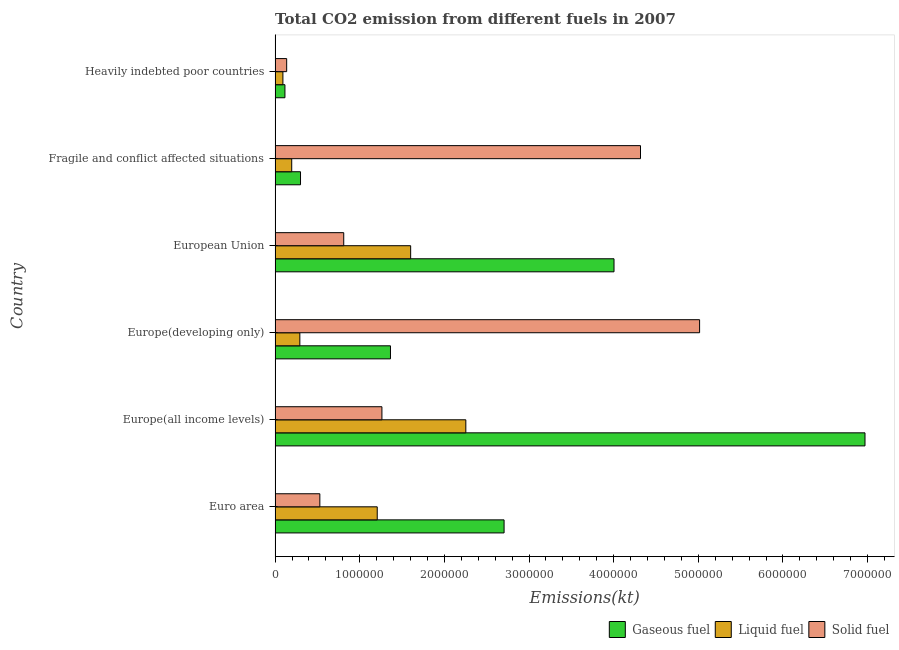What is the label of the 4th group of bars from the top?
Offer a very short reply. Europe(developing only). What is the amount of co2 emissions from liquid fuel in Heavily indebted poor countries?
Offer a terse response. 9.25e+04. Across all countries, what is the maximum amount of co2 emissions from solid fuel?
Make the answer very short. 5.02e+06. Across all countries, what is the minimum amount of co2 emissions from liquid fuel?
Keep it short and to the point. 9.25e+04. In which country was the amount of co2 emissions from solid fuel maximum?
Provide a succinct answer. Europe(developing only). In which country was the amount of co2 emissions from liquid fuel minimum?
Make the answer very short. Heavily indebted poor countries. What is the total amount of co2 emissions from solid fuel in the graph?
Provide a short and direct response. 1.21e+07. What is the difference between the amount of co2 emissions from solid fuel in Europe(developing only) and that in European Union?
Your answer should be very brief. 4.20e+06. What is the difference between the amount of co2 emissions from solid fuel in Europe(developing only) and the amount of co2 emissions from liquid fuel in Europe(all income levels)?
Offer a terse response. 2.76e+06. What is the average amount of co2 emissions from solid fuel per country?
Provide a short and direct response. 2.01e+06. What is the difference between the amount of co2 emissions from gaseous fuel and amount of co2 emissions from liquid fuel in Europe(developing only)?
Give a very brief answer. 1.07e+06. In how many countries, is the amount of co2 emissions from gaseous fuel greater than 3000000 kt?
Give a very brief answer. 2. What is the ratio of the amount of co2 emissions from gaseous fuel in Europe(all income levels) to that in Fragile and conflict affected situations?
Keep it short and to the point. 23.2. Is the difference between the amount of co2 emissions from solid fuel in Europe(all income levels) and European Union greater than the difference between the amount of co2 emissions from liquid fuel in Europe(all income levels) and European Union?
Provide a succinct answer. No. What is the difference between the highest and the second highest amount of co2 emissions from solid fuel?
Give a very brief answer. 6.98e+05. What is the difference between the highest and the lowest amount of co2 emissions from liquid fuel?
Ensure brevity in your answer.  2.16e+06. What does the 2nd bar from the top in Fragile and conflict affected situations represents?
Your answer should be compact. Liquid fuel. What does the 1st bar from the bottom in Fragile and conflict affected situations represents?
Provide a succinct answer. Gaseous fuel. How many bars are there?
Provide a succinct answer. 18. How many countries are there in the graph?
Give a very brief answer. 6. What is the difference between two consecutive major ticks on the X-axis?
Your response must be concise. 1.00e+06. Are the values on the major ticks of X-axis written in scientific E-notation?
Your answer should be compact. No. How many legend labels are there?
Your answer should be very brief. 3. How are the legend labels stacked?
Provide a short and direct response. Horizontal. What is the title of the graph?
Offer a very short reply. Total CO2 emission from different fuels in 2007. Does "Ages 20-60" appear as one of the legend labels in the graph?
Your answer should be compact. No. What is the label or title of the X-axis?
Your response must be concise. Emissions(kt). What is the label or title of the Y-axis?
Your answer should be very brief. Country. What is the Emissions(kt) in Gaseous fuel in Euro area?
Your answer should be compact. 2.71e+06. What is the Emissions(kt) of Liquid fuel in Euro area?
Your answer should be compact. 1.21e+06. What is the Emissions(kt) in Solid fuel in Euro area?
Your answer should be very brief. 5.29e+05. What is the Emissions(kt) in Gaseous fuel in Europe(all income levels)?
Make the answer very short. 6.97e+06. What is the Emissions(kt) in Liquid fuel in Europe(all income levels)?
Offer a terse response. 2.25e+06. What is the Emissions(kt) of Solid fuel in Europe(all income levels)?
Offer a terse response. 1.26e+06. What is the Emissions(kt) in Gaseous fuel in Europe(developing only)?
Ensure brevity in your answer.  1.36e+06. What is the Emissions(kt) of Liquid fuel in Europe(developing only)?
Your response must be concise. 2.93e+05. What is the Emissions(kt) of Solid fuel in Europe(developing only)?
Make the answer very short. 5.02e+06. What is the Emissions(kt) in Gaseous fuel in European Union?
Your response must be concise. 4.00e+06. What is the Emissions(kt) in Liquid fuel in European Union?
Keep it short and to the point. 1.60e+06. What is the Emissions(kt) of Solid fuel in European Union?
Offer a very short reply. 8.11e+05. What is the Emissions(kt) of Gaseous fuel in Fragile and conflict affected situations?
Provide a succinct answer. 3.00e+05. What is the Emissions(kt) of Liquid fuel in Fragile and conflict affected situations?
Your answer should be compact. 1.97e+05. What is the Emissions(kt) of Solid fuel in Fragile and conflict affected situations?
Make the answer very short. 4.32e+06. What is the Emissions(kt) in Gaseous fuel in Heavily indebted poor countries?
Offer a terse response. 1.16e+05. What is the Emissions(kt) of Liquid fuel in Heavily indebted poor countries?
Give a very brief answer. 9.25e+04. What is the Emissions(kt) of Solid fuel in Heavily indebted poor countries?
Ensure brevity in your answer.  1.37e+05. Across all countries, what is the maximum Emissions(kt) of Gaseous fuel?
Make the answer very short. 6.97e+06. Across all countries, what is the maximum Emissions(kt) in Liquid fuel?
Keep it short and to the point. 2.25e+06. Across all countries, what is the maximum Emissions(kt) in Solid fuel?
Your answer should be very brief. 5.02e+06. Across all countries, what is the minimum Emissions(kt) in Gaseous fuel?
Your answer should be very brief. 1.16e+05. Across all countries, what is the minimum Emissions(kt) in Liquid fuel?
Your answer should be compact. 9.25e+04. Across all countries, what is the minimum Emissions(kt) of Solid fuel?
Keep it short and to the point. 1.37e+05. What is the total Emissions(kt) in Gaseous fuel in the graph?
Offer a very short reply. 1.55e+07. What is the total Emissions(kt) in Liquid fuel in the graph?
Ensure brevity in your answer.  5.64e+06. What is the total Emissions(kt) in Solid fuel in the graph?
Provide a short and direct response. 1.21e+07. What is the difference between the Emissions(kt) in Gaseous fuel in Euro area and that in Europe(all income levels)?
Offer a very short reply. -4.26e+06. What is the difference between the Emissions(kt) in Liquid fuel in Euro area and that in Europe(all income levels)?
Your answer should be compact. -1.05e+06. What is the difference between the Emissions(kt) of Solid fuel in Euro area and that in Europe(all income levels)?
Offer a terse response. -7.33e+05. What is the difference between the Emissions(kt) in Gaseous fuel in Euro area and that in Europe(developing only)?
Provide a succinct answer. 1.34e+06. What is the difference between the Emissions(kt) in Liquid fuel in Euro area and that in Europe(developing only)?
Offer a very short reply. 9.14e+05. What is the difference between the Emissions(kt) of Solid fuel in Euro area and that in Europe(developing only)?
Your response must be concise. -4.49e+06. What is the difference between the Emissions(kt) of Gaseous fuel in Euro area and that in European Union?
Offer a very short reply. -1.30e+06. What is the difference between the Emissions(kt) of Liquid fuel in Euro area and that in European Union?
Keep it short and to the point. -3.95e+05. What is the difference between the Emissions(kt) of Solid fuel in Euro area and that in European Union?
Provide a short and direct response. -2.82e+05. What is the difference between the Emissions(kt) of Gaseous fuel in Euro area and that in Fragile and conflict affected situations?
Your response must be concise. 2.41e+06. What is the difference between the Emissions(kt) in Liquid fuel in Euro area and that in Fragile and conflict affected situations?
Your answer should be compact. 1.01e+06. What is the difference between the Emissions(kt) of Solid fuel in Euro area and that in Fragile and conflict affected situations?
Keep it short and to the point. -3.79e+06. What is the difference between the Emissions(kt) in Gaseous fuel in Euro area and that in Heavily indebted poor countries?
Give a very brief answer. 2.59e+06. What is the difference between the Emissions(kt) of Liquid fuel in Euro area and that in Heavily indebted poor countries?
Offer a very short reply. 1.11e+06. What is the difference between the Emissions(kt) in Solid fuel in Euro area and that in Heavily indebted poor countries?
Ensure brevity in your answer.  3.92e+05. What is the difference between the Emissions(kt) of Gaseous fuel in Europe(all income levels) and that in Europe(developing only)?
Make the answer very short. 5.61e+06. What is the difference between the Emissions(kt) of Liquid fuel in Europe(all income levels) and that in Europe(developing only)?
Offer a very short reply. 1.96e+06. What is the difference between the Emissions(kt) in Solid fuel in Europe(all income levels) and that in Europe(developing only)?
Keep it short and to the point. -3.75e+06. What is the difference between the Emissions(kt) in Gaseous fuel in Europe(all income levels) and that in European Union?
Provide a succinct answer. 2.97e+06. What is the difference between the Emissions(kt) in Liquid fuel in Europe(all income levels) and that in European Union?
Your answer should be very brief. 6.52e+05. What is the difference between the Emissions(kt) of Solid fuel in Europe(all income levels) and that in European Union?
Keep it short and to the point. 4.51e+05. What is the difference between the Emissions(kt) in Gaseous fuel in Europe(all income levels) and that in Fragile and conflict affected situations?
Your answer should be very brief. 6.67e+06. What is the difference between the Emissions(kt) in Liquid fuel in Europe(all income levels) and that in Fragile and conflict affected situations?
Your answer should be compact. 2.06e+06. What is the difference between the Emissions(kt) in Solid fuel in Europe(all income levels) and that in Fragile and conflict affected situations?
Offer a terse response. -3.05e+06. What is the difference between the Emissions(kt) of Gaseous fuel in Europe(all income levels) and that in Heavily indebted poor countries?
Your answer should be very brief. 6.85e+06. What is the difference between the Emissions(kt) of Liquid fuel in Europe(all income levels) and that in Heavily indebted poor countries?
Provide a succinct answer. 2.16e+06. What is the difference between the Emissions(kt) of Solid fuel in Europe(all income levels) and that in Heavily indebted poor countries?
Provide a succinct answer. 1.13e+06. What is the difference between the Emissions(kt) in Gaseous fuel in Europe(developing only) and that in European Union?
Offer a terse response. -2.64e+06. What is the difference between the Emissions(kt) in Liquid fuel in Europe(developing only) and that in European Union?
Ensure brevity in your answer.  -1.31e+06. What is the difference between the Emissions(kt) in Solid fuel in Europe(developing only) and that in European Union?
Your answer should be very brief. 4.20e+06. What is the difference between the Emissions(kt) in Gaseous fuel in Europe(developing only) and that in Fragile and conflict affected situations?
Offer a very short reply. 1.06e+06. What is the difference between the Emissions(kt) of Liquid fuel in Europe(developing only) and that in Fragile and conflict affected situations?
Make the answer very short. 9.60e+04. What is the difference between the Emissions(kt) in Solid fuel in Europe(developing only) and that in Fragile and conflict affected situations?
Your answer should be very brief. 6.98e+05. What is the difference between the Emissions(kt) in Gaseous fuel in Europe(developing only) and that in Heavily indebted poor countries?
Your answer should be compact. 1.25e+06. What is the difference between the Emissions(kt) of Liquid fuel in Europe(developing only) and that in Heavily indebted poor countries?
Your answer should be very brief. 2.00e+05. What is the difference between the Emissions(kt) of Solid fuel in Europe(developing only) and that in Heavily indebted poor countries?
Provide a succinct answer. 4.88e+06. What is the difference between the Emissions(kt) in Gaseous fuel in European Union and that in Fragile and conflict affected situations?
Make the answer very short. 3.70e+06. What is the difference between the Emissions(kt) of Liquid fuel in European Union and that in Fragile and conflict affected situations?
Keep it short and to the point. 1.41e+06. What is the difference between the Emissions(kt) of Solid fuel in European Union and that in Fragile and conflict affected situations?
Give a very brief answer. -3.51e+06. What is the difference between the Emissions(kt) of Gaseous fuel in European Union and that in Heavily indebted poor countries?
Your answer should be compact. 3.89e+06. What is the difference between the Emissions(kt) in Liquid fuel in European Union and that in Heavily indebted poor countries?
Keep it short and to the point. 1.51e+06. What is the difference between the Emissions(kt) in Solid fuel in European Union and that in Heavily indebted poor countries?
Keep it short and to the point. 6.74e+05. What is the difference between the Emissions(kt) of Gaseous fuel in Fragile and conflict affected situations and that in Heavily indebted poor countries?
Ensure brevity in your answer.  1.84e+05. What is the difference between the Emissions(kt) of Liquid fuel in Fragile and conflict affected situations and that in Heavily indebted poor countries?
Ensure brevity in your answer.  1.04e+05. What is the difference between the Emissions(kt) of Solid fuel in Fragile and conflict affected situations and that in Heavily indebted poor countries?
Provide a short and direct response. 4.18e+06. What is the difference between the Emissions(kt) in Gaseous fuel in Euro area and the Emissions(kt) in Liquid fuel in Europe(all income levels)?
Keep it short and to the point. 4.52e+05. What is the difference between the Emissions(kt) in Gaseous fuel in Euro area and the Emissions(kt) in Solid fuel in Europe(all income levels)?
Provide a succinct answer. 1.44e+06. What is the difference between the Emissions(kt) in Liquid fuel in Euro area and the Emissions(kt) in Solid fuel in Europe(all income levels)?
Your response must be concise. -5.55e+04. What is the difference between the Emissions(kt) of Gaseous fuel in Euro area and the Emissions(kt) of Liquid fuel in Europe(developing only)?
Keep it short and to the point. 2.41e+06. What is the difference between the Emissions(kt) of Gaseous fuel in Euro area and the Emissions(kt) of Solid fuel in Europe(developing only)?
Offer a terse response. -2.31e+06. What is the difference between the Emissions(kt) in Liquid fuel in Euro area and the Emissions(kt) in Solid fuel in Europe(developing only)?
Give a very brief answer. -3.81e+06. What is the difference between the Emissions(kt) of Gaseous fuel in Euro area and the Emissions(kt) of Liquid fuel in European Union?
Offer a terse response. 1.10e+06. What is the difference between the Emissions(kt) in Gaseous fuel in Euro area and the Emissions(kt) in Solid fuel in European Union?
Your response must be concise. 1.89e+06. What is the difference between the Emissions(kt) in Liquid fuel in Euro area and the Emissions(kt) in Solid fuel in European Union?
Your answer should be very brief. 3.96e+05. What is the difference between the Emissions(kt) in Gaseous fuel in Euro area and the Emissions(kt) in Liquid fuel in Fragile and conflict affected situations?
Make the answer very short. 2.51e+06. What is the difference between the Emissions(kt) in Gaseous fuel in Euro area and the Emissions(kt) in Solid fuel in Fragile and conflict affected situations?
Your answer should be very brief. -1.61e+06. What is the difference between the Emissions(kt) in Liquid fuel in Euro area and the Emissions(kt) in Solid fuel in Fragile and conflict affected situations?
Offer a very short reply. -3.11e+06. What is the difference between the Emissions(kt) of Gaseous fuel in Euro area and the Emissions(kt) of Liquid fuel in Heavily indebted poor countries?
Keep it short and to the point. 2.61e+06. What is the difference between the Emissions(kt) of Gaseous fuel in Euro area and the Emissions(kt) of Solid fuel in Heavily indebted poor countries?
Offer a very short reply. 2.57e+06. What is the difference between the Emissions(kt) in Liquid fuel in Euro area and the Emissions(kt) in Solid fuel in Heavily indebted poor countries?
Ensure brevity in your answer.  1.07e+06. What is the difference between the Emissions(kt) in Gaseous fuel in Europe(all income levels) and the Emissions(kt) in Liquid fuel in Europe(developing only)?
Your answer should be compact. 6.68e+06. What is the difference between the Emissions(kt) of Gaseous fuel in Europe(all income levels) and the Emissions(kt) of Solid fuel in Europe(developing only)?
Your response must be concise. 1.95e+06. What is the difference between the Emissions(kt) in Liquid fuel in Europe(all income levels) and the Emissions(kt) in Solid fuel in Europe(developing only)?
Provide a short and direct response. -2.76e+06. What is the difference between the Emissions(kt) of Gaseous fuel in Europe(all income levels) and the Emissions(kt) of Liquid fuel in European Union?
Provide a succinct answer. 5.37e+06. What is the difference between the Emissions(kt) in Gaseous fuel in Europe(all income levels) and the Emissions(kt) in Solid fuel in European Union?
Give a very brief answer. 6.16e+06. What is the difference between the Emissions(kt) in Liquid fuel in Europe(all income levels) and the Emissions(kt) in Solid fuel in European Union?
Offer a terse response. 1.44e+06. What is the difference between the Emissions(kt) in Gaseous fuel in Europe(all income levels) and the Emissions(kt) in Liquid fuel in Fragile and conflict affected situations?
Make the answer very short. 6.77e+06. What is the difference between the Emissions(kt) in Gaseous fuel in Europe(all income levels) and the Emissions(kt) in Solid fuel in Fragile and conflict affected situations?
Offer a terse response. 2.65e+06. What is the difference between the Emissions(kt) of Liquid fuel in Europe(all income levels) and the Emissions(kt) of Solid fuel in Fragile and conflict affected situations?
Offer a terse response. -2.06e+06. What is the difference between the Emissions(kt) in Gaseous fuel in Europe(all income levels) and the Emissions(kt) in Liquid fuel in Heavily indebted poor countries?
Offer a very short reply. 6.88e+06. What is the difference between the Emissions(kt) of Gaseous fuel in Europe(all income levels) and the Emissions(kt) of Solid fuel in Heavily indebted poor countries?
Keep it short and to the point. 6.83e+06. What is the difference between the Emissions(kt) of Liquid fuel in Europe(all income levels) and the Emissions(kt) of Solid fuel in Heavily indebted poor countries?
Offer a very short reply. 2.12e+06. What is the difference between the Emissions(kt) of Gaseous fuel in Europe(developing only) and the Emissions(kt) of Liquid fuel in European Union?
Offer a very short reply. -2.39e+05. What is the difference between the Emissions(kt) of Gaseous fuel in Europe(developing only) and the Emissions(kt) of Solid fuel in European Union?
Provide a short and direct response. 5.52e+05. What is the difference between the Emissions(kt) in Liquid fuel in Europe(developing only) and the Emissions(kt) in Solid fuel in European Union?
Provide a short and direct response. -5.18e+05. What is the difference between the Emissions(kt) of Gaseous fuel in Europe(developing only) and the Emissions(kt) of Liquid fuel in Fragile and conflict affected situations?
Your response must be concise. 1.17e+06. What is the difference between the Emissions(kt) of Gaseous fuel in Europe(developing only) and the Emissions(kt) of Solid fuel in Fragile and conflict affected situations?
Give a very brief answer. -2.95e+06. What is the difference between the Emissions(kt) in Liquid fuel in Europe(developing only) and the Emissions(kt) in Solid fuel in Fragile and conflict affected situations?
Give a very brief answer. -4.02e+06. What is the difference between the Emissions(kt) in Gaseous fuel in Europe(developing only) and the Emissions(kt) in Liquid fuel in Heavily indebted poor countries?
Offer a very short reply. 1.27e+06. What is the difference between the Emissions(kt) in Gaseous fuel in Europe(developing only) and the Emissions(kt) in Solid fuel in Heavily indebted poor countries?
Make the answer very short. 1.23e+06. What is the difference between the Emissions(kt) in Liquid fuel in Europe(developing only) and the Emissions(kt) in Solid fuel in Heavily indebted poor countries?
Make the answer very short. 1.56e+05. What is the difference between the Emissions(kt) of Gaseous fuel in European Union and the Emissions(kt) of Liquid fuel in Fragile and conflict affected situations?
Your response must be concise. 3.81e+06. What is the difference between the Emissions(kt) of Gaseous fuel in European Union and the Emissions(kt) of Solid fuel in Fragile and conflict affected situations?
Give a very brief answer. -3.13e+05. What is the difference between the Emissions(kt) in Liquid fuel in European Union and the Emissions(kt) in Solid fuel in Fragile and conflict affected situations?
Provide a short and direct response. -2.72e+06. What is the difference between the Emissions(kt) of Gaseous fuel in European Union and the Emissions(kt) of Liquid fuel in Heavily indebted poor countries?
Offer a very short reply. 3.91e+06. What is the difference between the Emissions(kt) in Gaseous fuel in European Union and the Emissions(kt) in Solid fuel in Heavily indebted poor countries?
Offer a very short reply. 3.87e+06. What is the difference between the Emissions(kt) of Liquid fuel in European Union and the Emissions(kt) of Solid fuel in Heavily indebted poor countries?
Offer a very short reply. 1.46e+06. What is the difference between the Emissions(kt) of Gaseous fuel in Fragile and conflict affected situations and the Emissions(kt) of Liquid fuel in Heavily indebted poor countries?
Your answer should be compact. 2.08e+05. What is the difference between the Emissions(kt) of Gaseous fuel in Fragile and conflict affected situations and the Emissions(kt) of Solid fuel in Heavily indebted poor countries?
Your answer should be compact. 1.64e+05. What is the difference between the Emissions(kt) of Liquid fuel in Fragile and conflict affected situations and the Emissions(kt) of Solid fuel in Heavily indebted poor countries?
Make the answer very short. 5.98e+04. What is the average Emissions(kt) of Gaseous fuel per country?
Give a very brief answer. 2.58e+06. What is the average Emissions(kt) in Liquid fuel per country?
Keep it short and to the point. 9.41e+05. What is the average Emissions(kt) of Solid fuel per country?
Give a very brief answer. 2.01e+06. What is the difference between the Emissions(kt) of Gaseous fuel and Emissions(kt) of Liquid fuel in Euro area?
Offer a very short reply. 1.50e+06. What is the difference between the Emissions(kt) in Gaseous fuel and Emissions(kt) in Solid fuel in Euro area?
Keep it short and to the point. 2.18e+06. What is the difference between the Emissions(kt) of Liquid fuel and Emissions(kt) of Solid fuel in Euro area?
Your answer should be compact. 6.78e+05. What is the difference between the Emissions(kt) of Gaseous fuel and Emissions(kt) of Liquid fuel in Europe(all income levels)?
Keep it short and to the point. 4.72e+06. What is the difference between the Emissions(kt) of Gaseous fuel and Emissions(kt) of Solid fuel in Europe(all income levels)?
Make the answer very short. 5.71e+06. What is the difference between the Emissions(kt) in Liquid fuel and Emissions(kt) in Solid fuel in Europe(all income levels)?
Provide a short and direct response. 9.91e+05. What is the difference between the Emissions(kt) in Gaseous fuel and Emissions(kt) in Liquid fuel in Europe(developing only)?
Your answer should be very brief. 1.07e+06. What is the difference between the Emissions(kt) of Gaseous fuel and Emissions(kt) of Solid fuel in Europe(developing only)?
Offer a very short reply. -3.65e+06. What is the difference between the Emissions(kt) in Liquid fuel and Emissions(kt) in Solid fuel in Europe(developing only)?
Offer a terse response. -4.72e+06. What is the difference between the Emissions(kt) of Gaseous fuel and Emissions(kt) of Liquid fuel in European Union?
Offer a terse response. 2.40e+06. What is the difference between the Emissions(kt) in Gaseous fuel and Emissions(kt) in Solid fuel in European Union?
Your answer should be very brief. 3.19e+06. What is the difference between the Emissions(kt) in Liquid fuel and Emissions(kt) in Solid fuel in European Union?
Provide a short and direct response. 7.91e+05. What is the difference between the Emissions(kt) in Gaseous fuel and Emissions(kt) in Liquid fuel in Fragile and conflict affected situations?
Keep it short and to the point. 1.04e+05. What is the difference between the Emissions(kt) of Gaseous fuel and Emissions(kt) of Solid fuel in Fragile and conflict affected situations?
Your answer should be compact. -4.02e+06. What is the difference between the Emissions(kt) in Liquid fuel and Emissions(kt) in Solid fuel in Fragile and conflict affected situations?
Keep it short and to the point. -4.12e+06. What is the difference between the Emissions(kt) of Gaseous fuel and Emissions(kt) of Liquid fuel in Heavily indebted poor countries?
Make the answer very short. 2.39e+04. What is the difference between the Emissions(kt) of Gaseous fuel and Emissions(kt) of Solid fuel in Heavily indebted poor countries?
Give a very brief answer. -2.05e+04. What is the difference between the Emissions(kt) in Liquid fuel and Emissions(kt) in Solid fuel in Heavily indebted poor countries?
Your answer should be very brief. -4.43e+04. What is the ratio of the Emissions(kt) in Gaseous fuel in Euro area to that in Europe(all income levels)?
Provide a short and direct response. 0.39. What is the ratio of the Emissions(kt) in Liquid fuel in Euro area to that in Europe(all income levels)?
Provide a succinct answer. 0.54. What is the ratio of the Emissions(kt) of Solid fuel in Euro area to that in Europe(all income levels)?
Provide a succinct answer. 0.42. What is the ratio of the Emissions(kt) in Gaseous fuel in Euro area to that in Europe(developing only)?
Make the answer very short. 1.98. What is the ratio of the Emissions(kt) in Liquid fuel in Euro area to that in Europe(developing only)?
Ensure brevity in your answer.  4.12. What is the ratio of the Emissions(kt) in Solid fuel in Euro area to that in Europe(developing only)?
Your answer should be compact. 0.11. What is the ratio of the Emissions(kt) of Gaseous fuel in Euro area to that in European Union?
Ensure brevity in your answer.  0.68. What is the ratio of the Emissions(kt) of Liquid fuel in Euro area to that in European Union?
Provide a succinct answer. 0.75. What is the ratio of the Emissions(kt) of Solid fuel in Euro area to that in European Union?
Ensure brevity in your answer.  0.65. What is the ratio of the Emissions(kt) of Gaseous fuel in Euro area to that in Fragile and conflict affected situations?
Provide a succinct answer. 9.01. What is the ratio of the Emissions(kt) of Liquid fuel in Euro area to that in Fragile and conflict affected situations?
Give a very brief answer. 6.14. What is the ratio of the Emissions(kt) in Solid fuel in Euro area to that in Fragile and conflict affected situations?
Offer a terse response. 0.12. What is the ratio of the Emissions(kt) of Gaseous fuel in Euro area to that in Heavily indebted poor countries?
Your answer should be very brief. 23.24. What is the ratio of the Emissions(kt) of Liquid fuel in Euro area to that in Heavily indebted poor countries?
Make the answer very short. 13.04. What is the ratio of the Emissions(kt) in Solid fuel in Euro area to that in Heavily indebted poor countries?
Provide a short and direct response. 3.86. What is the ratio of the Emissions(kt) of Gaseous fuel in Europe(all income levels) to that in Europe(developing only)?
Ensure brevity in your answer.  5.11. What is the ratio of the Emissions(kt) of Liquid fuel in Europe(all income levels) to that in Europe(developing only)?
Your answer should be very brief. 7.7. What is the ratio of the Emissions(kt) in Solid fuel in Europe(all income levels) to that in Europe(developing only)?
Your answer should be compact. 0.25. What is the ratio of the Emissions(kt) in Gaseous fuel in Europe(all income levels) to that in European Union?
Provide a short and direct response. 1.74. What is the ratio of the Emissions(kt) in Liquid fuel in Europe(all income levels) to that in European Union?
Your response must be concise. 1.41. What is the ratio of the Emissions(kt) of Solid fuel in Europe(all income levels) to that in European Union?
Your answer should be compact. 1.56. What is the ratio of the Emissions(kt) in Gaseous fuel in Europe(all income levels) to that in Fragile and conflict affected situations?
Give a very brief answer. 23.2. What is the ratio of the Emissions(kt) in Liquid fuel in Europe(all income levels) to that in Fragile and conflict affected situations?
Provide a short and direct response. 11.46. What is the ratio of the Emissions(kt) of Solid fuel in Europe(all income levels) to that in Fragile and conflict affected situations?
Your answer should be very brief. 0.29. What is the ratio of the Emissions(kt) in Gaseous fuel in Europe(all income levels) to that in Heavily indebted poor countries?
Make the answer very short. 59.87. What is the ratio of the Emissions(kt) of Liquid fuel in Europe(all income levels) to that in Heavily indebted poor countries?
Provide a short and direct response. 24.35. What is the ratio of the Emissions(kt) of Solid fuel in Europe(all income levels) to that in Heavily indebted poor countries?
Give a very brief answer. 9.22. What is the ratio of the Emissions(kt) in Gaseous fuel in Europe(developing only) to that in European Union?
Make the answer very short. 0.34. What is the ratio of the Emissions(kt) of Liquid fuel in Europe(developing only) to that in European Union?
Offer a very short reply. 0.18. What is the ratio of the Emissions(kt) in Solid fuel in Europe(developing only) to that in European Union?
Ensure brevity in your answer.  6.18. What is the ratio of the Emissions(kt) in Gaseous fuel in Europe(developing only) to that in Fragile and conflict affected situations?
Give a very brief answer. 4.54. What is the ratio of the Emissions(kt) of Liquid fuel in Europe(developing only) to that in Fragile and conflict affected situations?
Provide a succinct answer. 1.49. What is the ratio of the Emissions(kt) in Solid fuel in Europe(developing only) to that in Fragile and conflict affected situations?
Offer a terse response. 1.16. What is the ratio of the Emissions(kt) of Gaseous fuel in Europe(developing only) to that in Heavily indebted poor countries?
Provide a succinct answer. 11.71. What is the ratio of the Emissions(kt) in Liquid fuel in Europe(developing only) to that in Heavily indebted poor countries?
Provide a short and direct response. 3.16. What is the ratio of the Emissions(kt) of Solid fuel in Europe(developing only) to that in Heavily indebted poor countries?
Give a very brief answer. 36.64. What is the ratio of the Emissions(kt) in Gaseous fuel in European Union to that in Fragile and conflict affected situations?
Your answer should be compact. 13.33. What is the ratio of the Emissions(kt) of Liquid fuel in European Union to that in Fragile and conflict affected situations?
Keep it short and to the point. 8.14. What is the ratio of the Emissions(kt) of Solid fuel in European Union to that in Fragile and conflict affected situations?
Ensure brevity in your answer.  0.19. What is the ratio of the Emissions(kt) in Gaseous fuel in European Union to that in Heavily indebted poor countries?
Ensure brevity in your answer.  34.4. What is the ratio of the Emissions(kt) of Liquid fuel in European Union to that in Heavily indebted poor countries?
Offer a terse response. 17.31. What is the ratio of the Emissions(kt) of Solid fuel in European Union to that in Heavily indebted poor countries?
Give a very brief answer. 5.93. What is the ratio of the Emissions(kt) of Gaseous fuel in Fragile and conflict affected situations to that in Heavily indebted poor countries?
Your response must be concise. 2.58. What is the ratio of the Emissions(kt) of Liquid fuel in Fragile and conflict affected situations to that in Heavily indebted poor countries?
Give a very brief answer. 2.12. What is the ratio of the Emissions(kt) of Solid fuel in Fragile and conflict affected situations to that in Heavily indebted poor countries?
Ensure brevity in your answer.  31.54. What is the difference between the highest and the second highest Emissions(kt) of Gaseous fuel?
Your response must be concise. 2.97e+06. What is the difference between the highest and the second highest Emissions(kt) of Liquid fuel?
Keep it short and to the point. 6.52e+05. What is the difference between the highest and the second highest Emissions(kt) of Solid fuel?
Provide a succinct answer. 6.98e+05. What is the difference between the highest and the lowest Emissions(kt) in Gaseous fuel?
Your answer should be compact. 6.85e+06. What is the difference between the highest and the lowest Emissions(kt) of Liquid fuel?
Provide a succinct answer. 2.16e+06. What is the difference between the highest and the lowest Emissions(kt) of Solid fuel?
Your answer should be compact. 4.88e+06. 